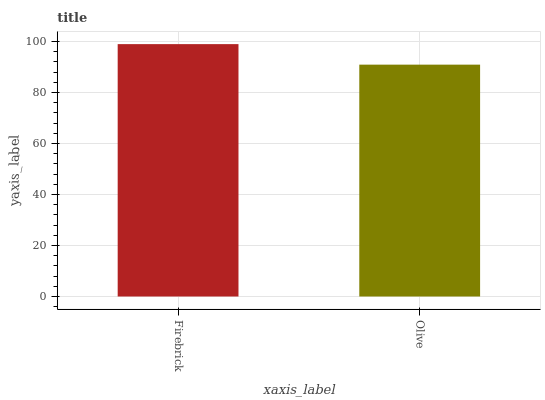Is Olive the minimum?
Answer yes or no. Yes. Is Firebrick the maximum?
Answer yes or no. Yes. Is Olive the maximum?
Answer yes or no. No. Is Firebrick greater than Olive?
Answer yes or no. Yes. Is Olive less than Firebrick?
Answer yes or no. Yes. Is Olive greater than Firebrick?
Answer yes or no. No. Is Firebrick less than Olive?
Answer yes or no. No. Is Firebrick the high median?
Answer yes or no. Yes. Is Olive the low median?
Answer yes or no. Yes. Is Olive the high median?
Answer yes or no. No. Is Firebrick the low median?
Answer yes or no. No. 